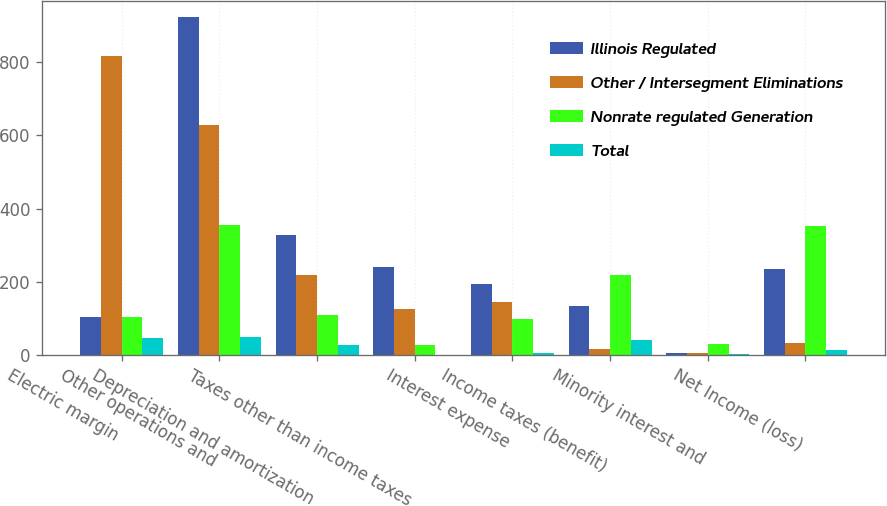Convert chart. <chart><loc_0><loc_0><loc_500><loc_500><stacked_bar_chart><ecel><fcel>Electric margin<fcel>Other operations and<fcel>Depreciation and amortization<fcel>Taxes other than income taxes<fcel>Interest expense<fcel>Income taxes (benefit)<fcel>Minority interest and<fcel>Net Income (loss)<nl><fcel>Illinois Regulated<fcel>104<fcel>922<fcel>329<fcel>240<fcel>193<fcel>134<fcel>6<fcel>234<nl><fcel>Other / Intersegment Eliminations<fcel>817<fcel>627<fcel>219<fcel>126<fcel>144<fcel>16<fcel>6<fcel>32<nl><fcel>Nonrate regulated Generation<fcel>104<fcel>356<fcel>109<fcel>26<fcel>99<fcel>217<fcel>29<fcel>352<nl><fcel>Total<fcel>47<fcel>48<fcel>28<fcel>1<fcel>4<fcel>40<fcel>2<fcel>13<nl></chart> 